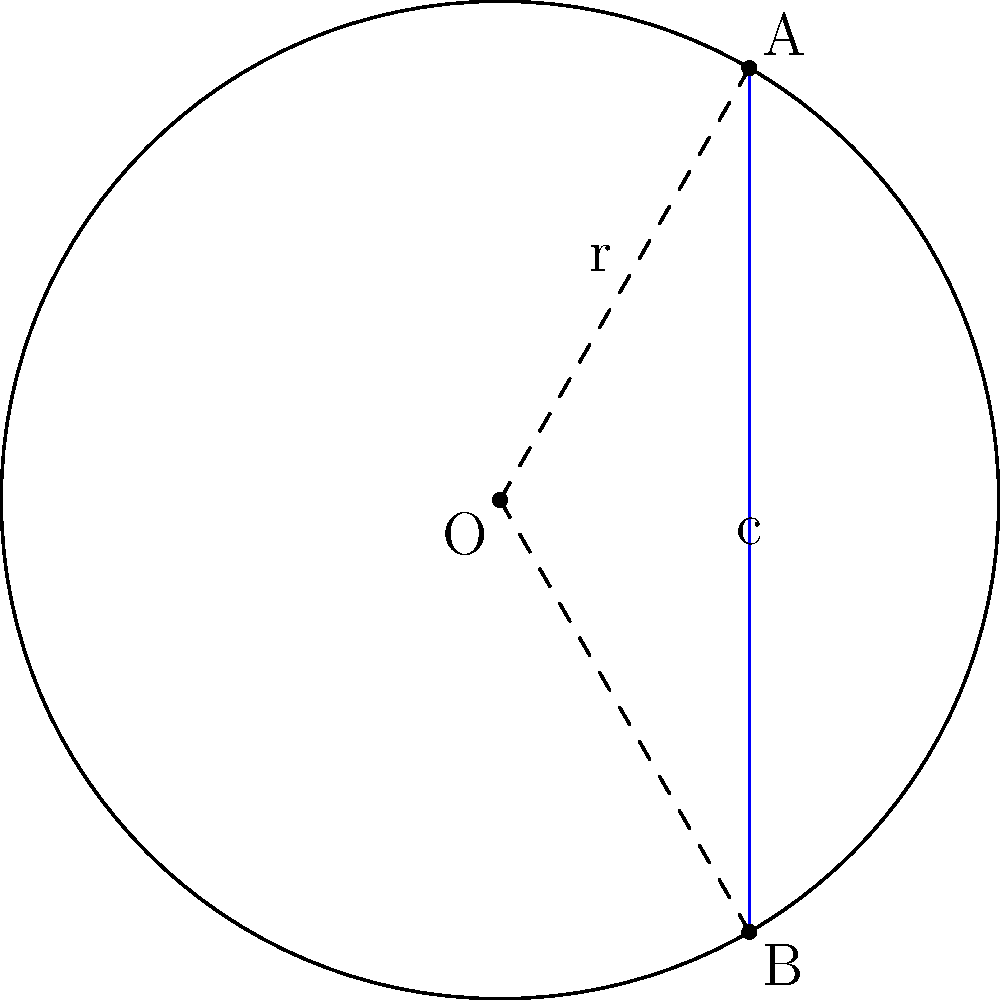As a drummer, you're always mindful of the circular arrangement of your drum kit. Imagine your largest drum has a radius of 12 inches, and you're trying to position two cymbals at the edge, forming a chord. If the angle between the radii to these cymbals is 60°, what is the length of the chord (distance between the cymbals)? Round your answer to the nearest inch. Let's approach this step-by-step:

1) In the diagram, O represents the center of the circle (your drum), A and B are the positions of the cymbals, and the blue line AB is the chord we're trying to find.

2) We're given:
   - Radius (r) = 12 inches
   - Central angle (θ) = 60°

3) To find the length of the chord, we can use the formula:
   $c = 2r \sin(\frac{\theta}{2})$

   Where:
   c = chord length
   r = radius
   θ = central angle in radians

4) First, we need to convert 60° to radians:
   $60° \times \frac{\pi}{180°} = \frac{\pi}{3}$ radians

5) Now we can plug everything into our formula:
   $c = 2 \times 12 \times \sin(\frac{\pi}{6})$

6) $\sin(\frac{\pi}{6}) = \frac{1}{2}$, so:
   $c = 2 \times 12 \times \frac{1}{2} = 12$ inches

7) The question asks to round to the nearest inch, but our answer is already a whole number.

Therefore, the length of the chord (distance between the cymbals) is 12 inches.
Answer: 12 inches 